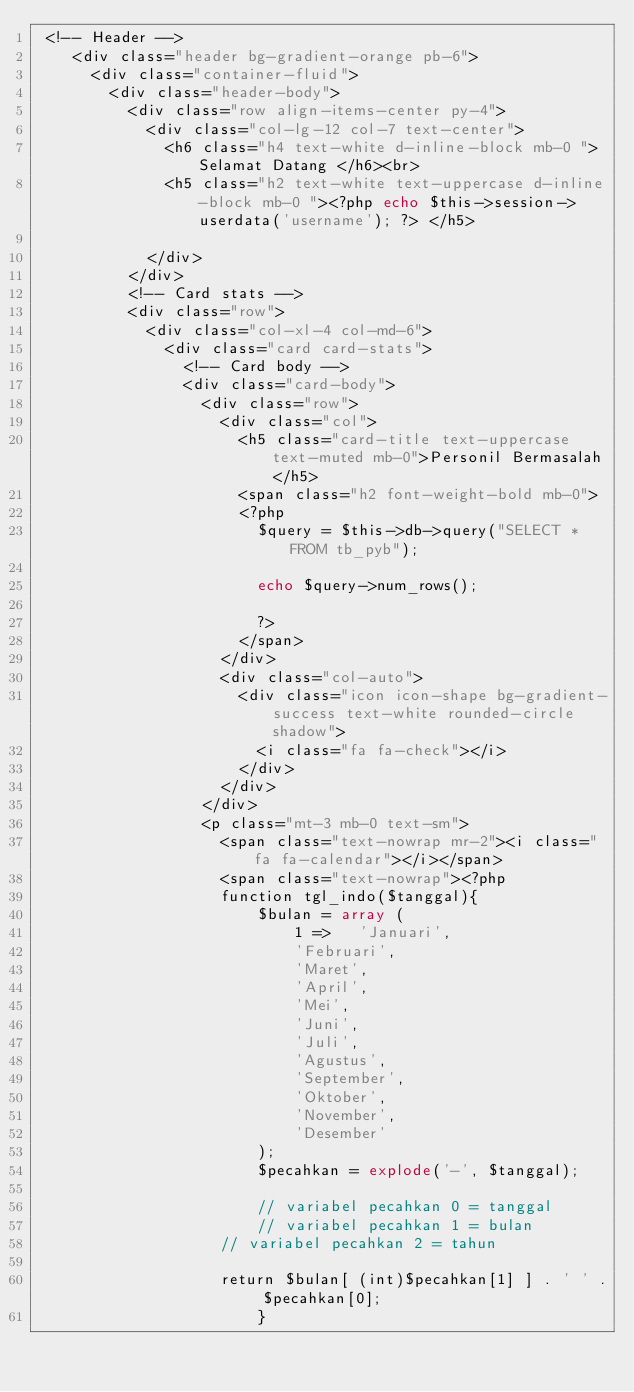Convert code to text. <code><loc_0><loc_0><loc_500><loc_500><_PHP_> <!-- Header -->
    <div class="header bg-gradient-orange pb-6">
      <div class="container-fluid">
        <div class="header-body">
          <div class="row align-items-center py-4">
            <div class="col-lg-12 col-7 text-center">
              <h6 class="h4 text-white d-inline-block mb-0 ">Selamat Datang </h6><br>
              <h5 class="h2 text-white text-uppercase d-inline-block mb-0 "><?php echo $this->session->userdata('username'); ?> </h5>
              
            </div>
          </div>
          <!-- Card stats -->
          <div class="row">
            <div class="col-xl-4 col-md-6">
              <div class="card card-stats">
                <!-- Card body -->
                <div class="card-body">
                  <div class="row">
                    <div class="col">
                      <h5 class="card-title text-uppercase text-muted mb-0">Personil Bermasalah</h5>
                      <span class="h2 font-weight-bold mb-0">
                      <?php 
                        $query = $this->db->query("SELECT * FROM tb_pyb");

                        echo $query->num_rows();

                        ?>
                      </span>
                    </div>
                    <div class="col-auto">
                      <div class="icon icon-shape bg-gradient-success text-white rounded-circle shadow">
                        <i class="fa fa-check"></i>
                      </div>
                    </div>
                  </div>
                  <p class="mt-3 mb-0 text-sm">
                    <span class="text-nowrap mr-2"><i class="fa fa-calendar"></i></span>
                    <span class="text-nowrap"><?php 
                    function tgl_indo($tanggal){
                        $bulan = array (
                            1 =>   'Januari',
                            'Februari',
                            'Maret',
                            'April',
                            'Mei',
                            'Juni',
                            'Juli',
                            'Agustus',
                            'September',
                            'Oktober',
                            'November',
                            'Desember'
                        );
                        $pecahkan = explode('-', $tanggal);
                        
                        // variabel pecahkan 0 = tanggal
                        // variabel pecahkan 1 = bulan
                    // variabel pecahkan 2 = tahun
                 
                    return $bulan[ (int)$pecahkan[1] ] . ' ' . $pecahkan[0];
                        }
                 </code> 